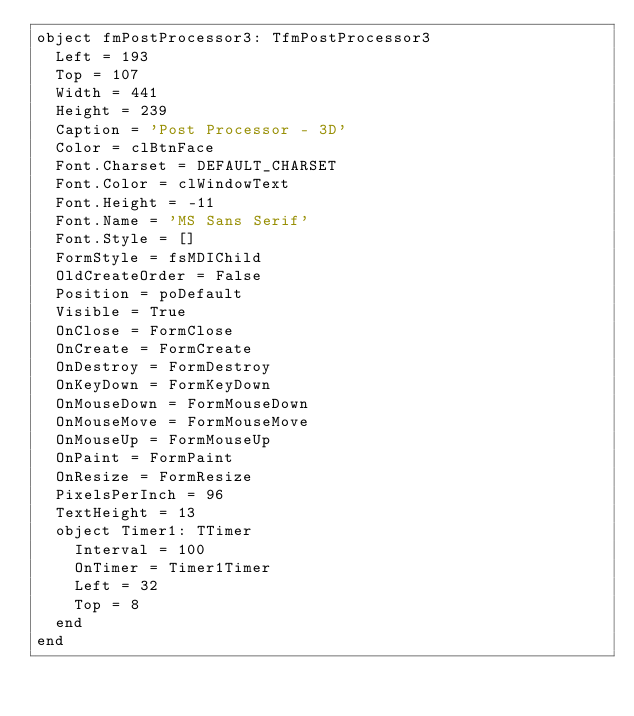<code> <loc_0><loc_0><loc_500><loc_500><_Pascal_>object fmPostProcessor3: TfmPostProcessor3
  Left = 193
  Top = 107
  Width = 441
  Height = 239
  Caption = 'Post Processor - 3D'
  Color = clBtnFace
  Font.Charset = DEFAULT_CHARSET
  Font.Color = clWindowText
  Font.Height = -11
  Font.Name = 'MS Sans Serif'
  Font.Style = []
  FormStyle = fsMDIChild
  OldCreateOrder = False
  Position = poDefault
  Visible = True
  OnClose = FormClose
  OnCreate = FormCreate
  OnDestroy = FormDestroy
  OnKeyDown = FormKeyDown
  OnMouseDown = FormMouseDown
  OnMouseMove = FormMouseMove
  OnMouseUp = FormMouseUp
  OnPaint = FormPaint
  OnResize = FormResize
  PixelsPerInch = 96
  TextHeight = 13
  object Timer1: TTimer
    Interval = 100
    OnTimer = Timer1Timer
    Left = 32
    Top = 8
  end
end
</code> 